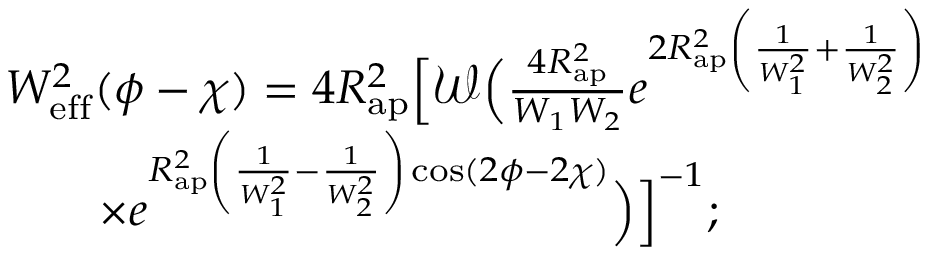<formula> <loc_0><loc_0><loc_500><loc_500>\begin{array} { r l } & { W _ { e f f } ^ { 2 } ( \phi - \chi ) = 4 R _ { a p } ^ { 2 } \left [ \mathcal { W } \left ( \frac { 4 R _ { a p } ^ { 2 } } { W _ { 1 } W _ { 2 } } e ^ { 2 R _ { a p } ^ { 2 } \left ( \frac { 1 } { W _ { 1 } ^ { 2 } } + \frac { 1 } { W _ { 2 } ^ { 2 } } \right ) } \Big . \Big . } \\ & { \quad \times \Big . \Big . e ^ { R _ { a p } ^ { 2 } \left ( \frac { 1 } { W _ { 1 } ^ { 2 } } - \frac { 1 } { W _ { 2 } ^ { 2 } } \right ) \cos ( 2 \phi - 2 \chi ) } \right ) \right ] ^ { - 1 } ; } \end{array}</formula> 